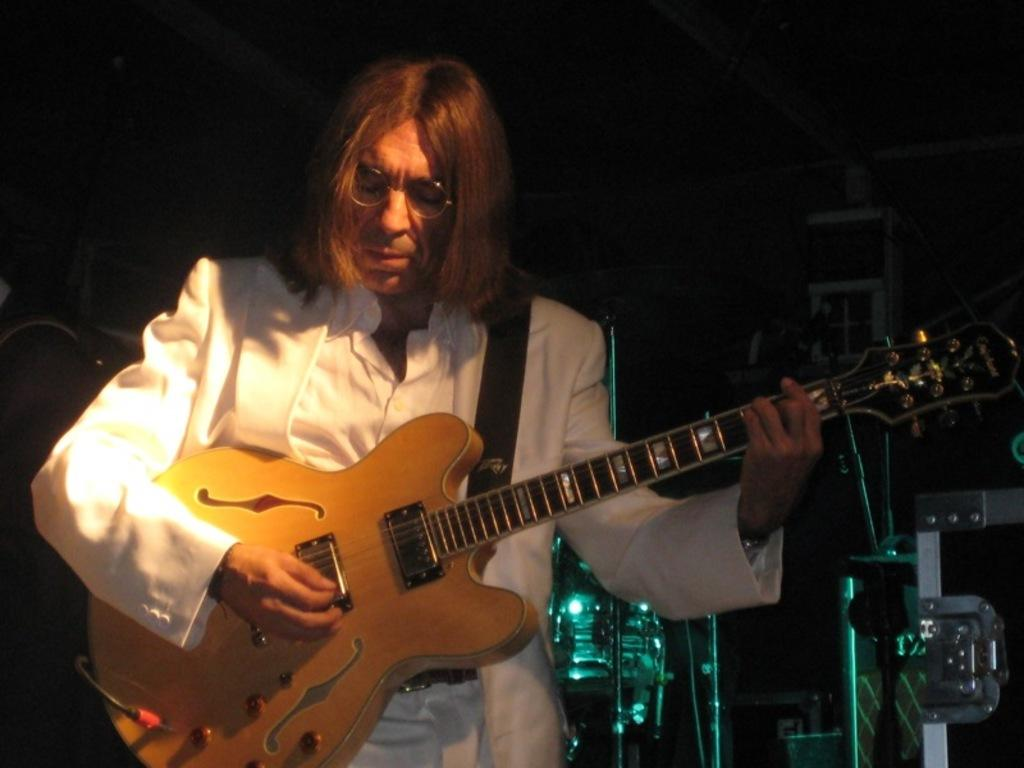What is the main subject of the image? There is a man in the image. What is the man doing in the image? The man is standing in the image. What object is the man holding in his hand? The man is holding a guitar in his hand. What type of good-bye message is the man sending through the vessel in the image? There is no vessel or good-bye message present in the image; it features a man standing and holding a guitar. 